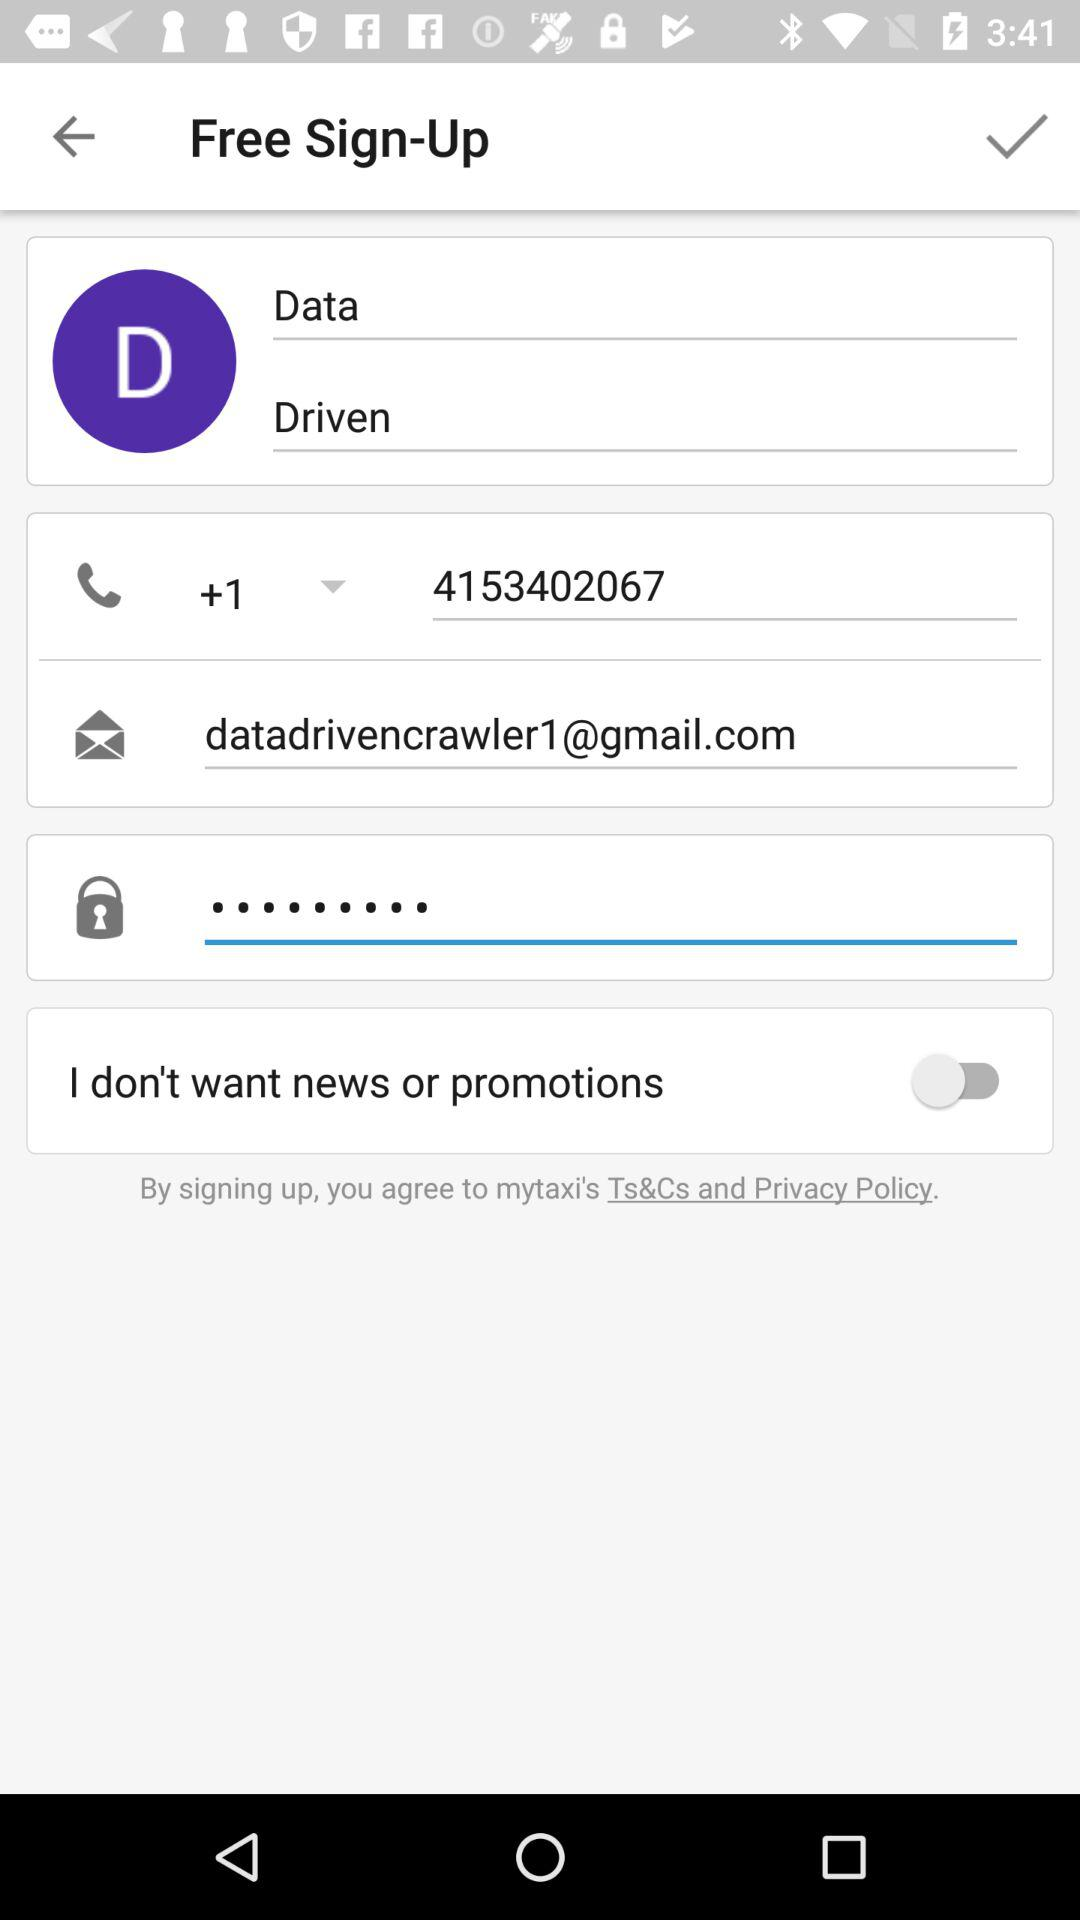What is the contact number of the user? The contact number of the user is +1 4153402067. 